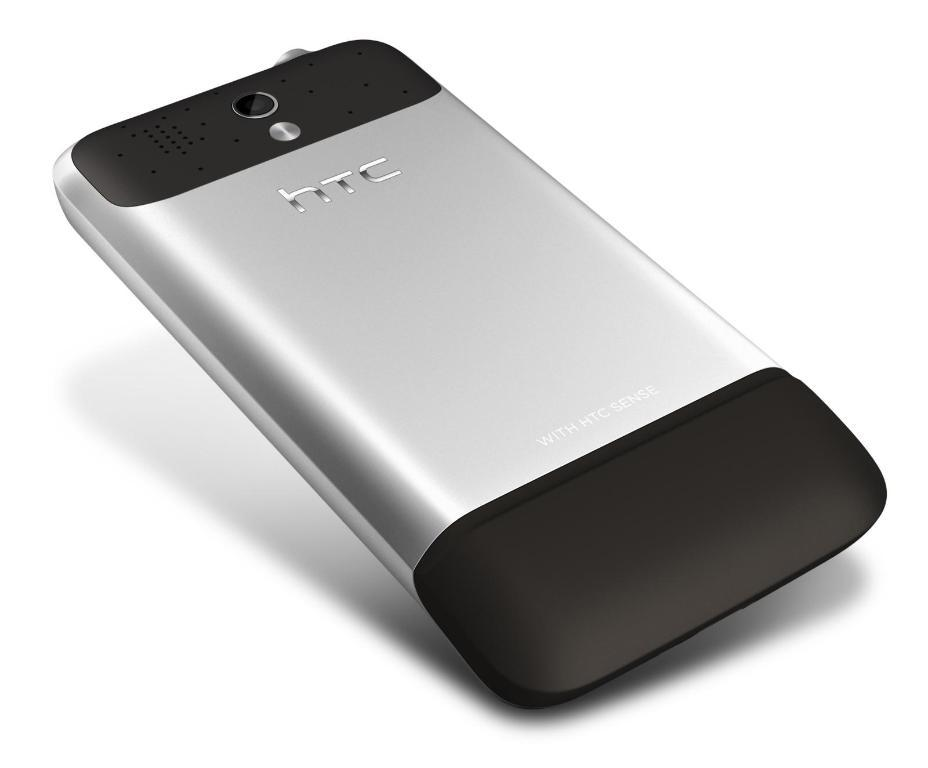<image>
Give a short and clear explanation of the subsequent image. A silver and black phone says HTC on the back. 